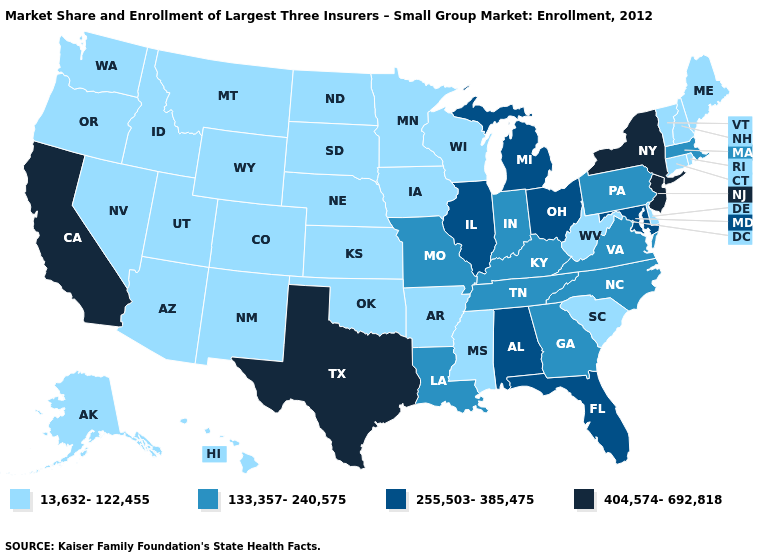Name the states that have a value in the range 255,503-385,475?
Write a very short answer. Alabama, Florida, Illinois, Maryland, Michigan, Ohio. What is the value of Hawaii?
Concise answer only. 13,632-122,455. Name the states that have a value in the range 133,357-240,575?
Keep it brief. Georgia, Indiana, Kentucky, Louisiana, Massachusetts, Missouri, North Carolina, Pennsylvania, Tennessee, Virginia. Name the states that have a value in the range 255,503-385,475?
Concise answer only. Alabama, Florida, Illinois, Maryland, Michigan, Ohio. Name the states that have a value in the range 133,357-240,575?
Short answer required. Georgia, Indiana, Kentucky, Louisiana, Massachusetts, Missouri, North Carolina, Pennsylvania, Tennessee, Virginia. Name the states that have a value in the range 404,574-692,818?
Quick response, please. California, New Jersey, New York, Texas. Among the states that border Iowa , which have the highest value?
Write a very short answer. Illinois. Name the states that have a value in the range 255,503-385,475?
Quick response, please. Alabama, Florida, Illinois, Maryland, Michigan, Ohio. Name the states that have a value in the range 13,632-122,455?
Quick response, please. Alaska, Arizona, Arkansas, Colorado, Connecticut, Delaware, Hawaii, Idaho, Iowa, Kansas, Maine, Minnesota, Mississippi, Montana, Nebraska, Nevada, New Hampshire, New Mexico, North Dakota, Oklahoma, Oregon, Rhode Island, South Carolina, South Dakota, Utah, Vermont, Washington, West Virginia, Wisconsin, Wyoming. Name the states that have a value in the range 133,357-240,575?
Give a very brief answer. Georgia, Indiana, Kentucky, Louisiana, Massachusetts, Missouri, North Carolina, Pennsylvania, Tennessee, Virginia. Is the legend a continuous bar?
Concise answer only. No. How many symbols are there in the legend?
Keep it brief. 4. Is the legend a continuous bar?
Keep it brief. No. Name the states that have a value in the range 13,632-122,455?
Give a very brief answer. Alaska, Arizona, Arkansas, Colorado, Connecticut, Delaware, Hawaii, Idaho, Iowa, Kansas, Maine, Minnesota, Mississippi, Montana, Nebraska, Nevada, New Hampshire, New Mexico, North Dakota, Oklahoma, Oregon, Rhode Island, South Carolina, South Dakota, Utah, Vermont, Washington, West Virginia, Wisconsin, Wyoming. Name the states that have a value in the range 13,632-122,455?
Short answer required. Alaska, Arizona, Arkansas, Colorado, Connecticut, Delaware, Hawaii, Idaho, Iowa, Kansas, Maine, Minnesota, Mississippi, Montana, Nebraska, Nevada, New Hampshire, New Mexico, North Dakota, Oklahoma, Oregon, Rhode Island, South Carolina, South Dakota, Utah, Vermont, Washington, West Virginia, Wisconsin, Wyoming. 